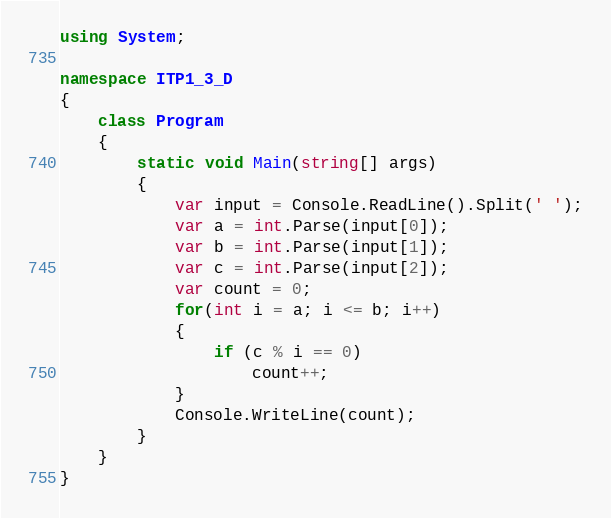<code> <loc_0><loc_0><loc_500><loc_500><_C#_>using System;

namespace ITP1_3_D
{
    class Program
    {
        static void Main(string[] args)
        {
            var input = Console.ReadLine().Split(' ');
            var a = int.Parse(input[0]);
            var b = int.Parse(input[1]);
            var c = int.Parse(input[2]);
            var count = 0;
            for(int i = a; i <= b; i++)
            {
                if (c % i == 0)
                    count++;
            }
            Console.WriteLine(count);
        }
    }
}</code> 